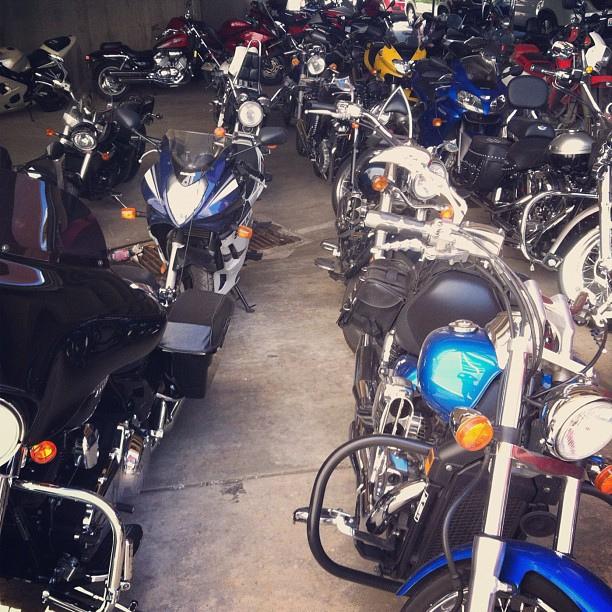Is this a club?
Short answer required. Yes. Are there people here?
Answer briefly. No. Are these motorcycles for racing?
Be succinct. No. 